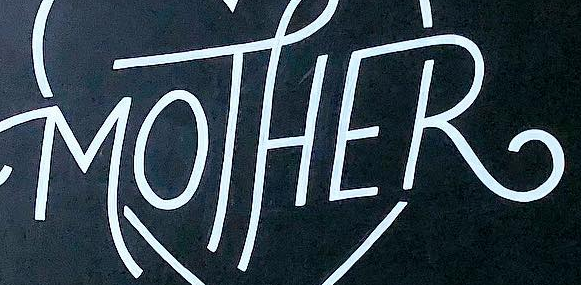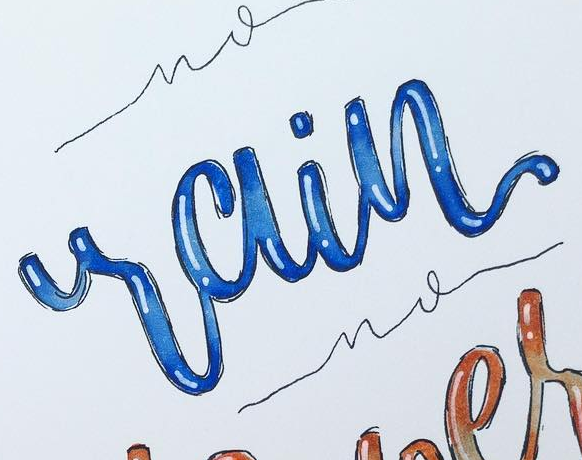Transcribe the words shown in these images in order, separated by a semicolon. MOTHER; rain 